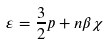Convert formula to latex. <formula><loc_0><loc_0><loc_500><loc_500>\varepsilon = \frac { 3 } { 2 } p + n \beta \chi</formula> 